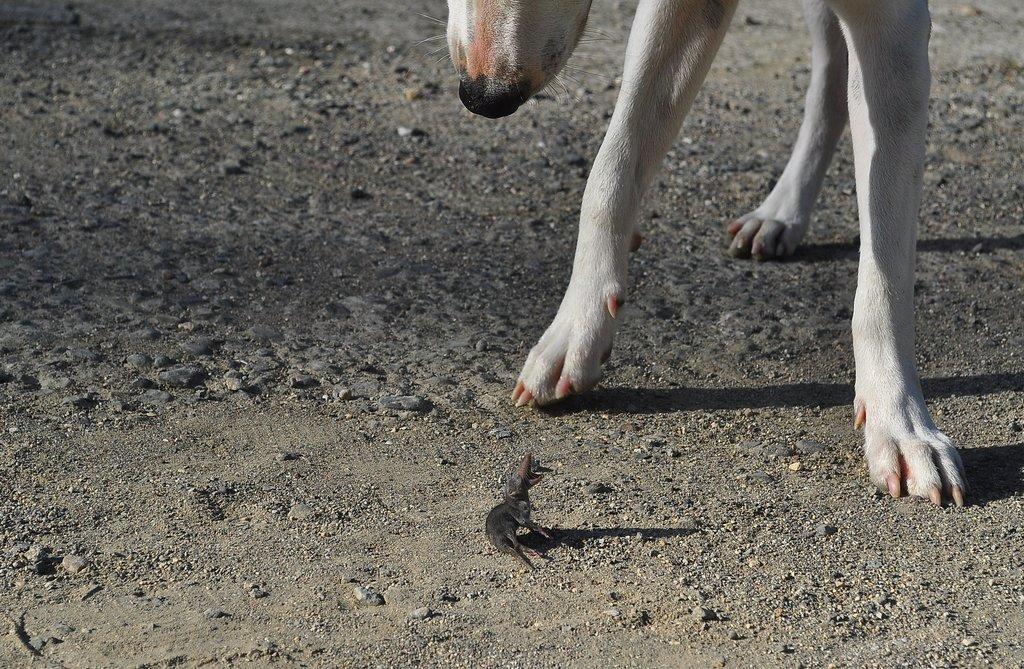How would you summarize this image in a sentence or two? In the foreground of this image, it seems like an animal on the ground. At the top, there is a dog. 